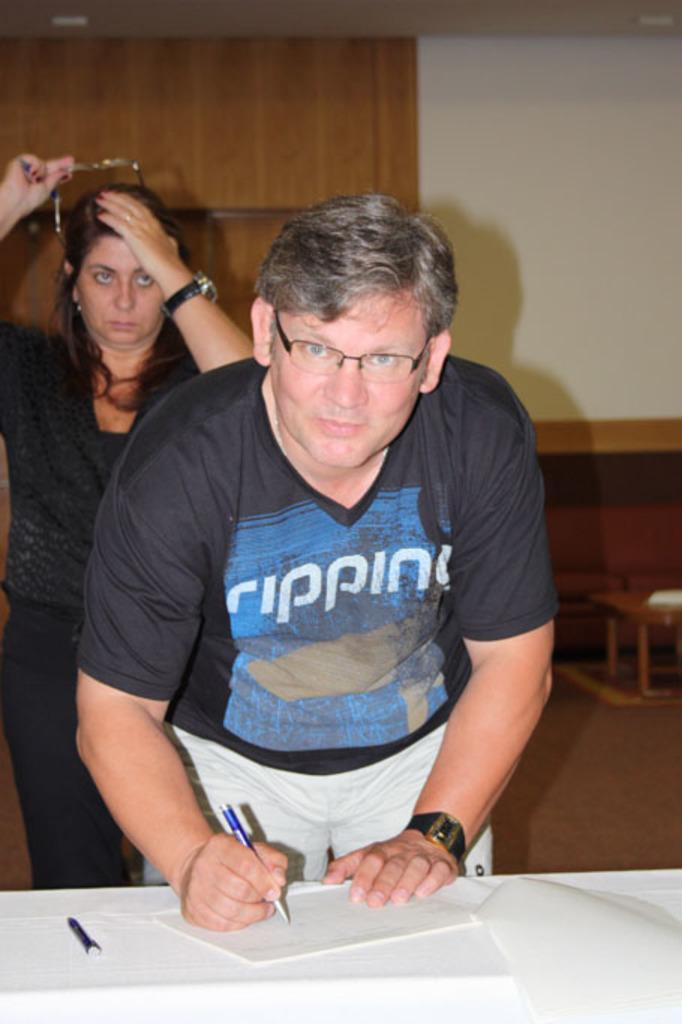How many people are in the image? There are two people in the image, a man and a woman. What is the man doing in the image? The man is writing on a paper with a pen. Where are the paper and pen located? The paper and pen are on a table. How is the table positioned in relation to the man? The table is in front of the man. What can be observed about the room in the image? The room contains tables and chairs. What type of cough can be heard from the cat in the image? There is no cat present in the image, and therefore no cough can be heard. What color is the boot that the man is wearing in the image? The man is not wearing a boot in the image; he is wearing regular shoes. 